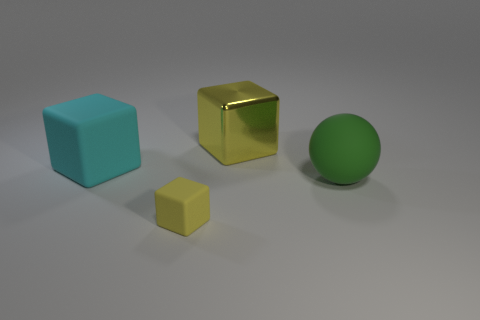There is a large yellow object that is the same shape as the small yellow matte thing; what is its material?
Your response must be concise. Metal. The yellow object that is in front of the shiny object has what shape?
Give a very brief answer. Cube. Is there any other thing that is the same color as the matte ball?
Keep it short and to the point. No. Are there fewer tiny yellow objects on the left side of the tiny rubber thing than big blocks?
Your response must be concise. Yes. What number of rubber spheres are the same size as the yellow metallic block?
Offer a very short reply. 1. What is the shape of the matte object that is the same color as the big metal object?
Your answer should be very brief. Cube. There is a big green rubber object on the right side of the large cube to the left of the large block that is behind the large cyan block; what is its shape?
Keep it short and to the point. Sphere. What is the color of the thing that is behind the cyan block?
Provide a succinct answer. Yellow. How many objects are either objects that are on the right side of the metal object or cubes behind the tiny yellow block?
Your answer should be compact. 3. What number of yellow rubber things are the same shape as the cyan object?
Give a very brief answer. 1. 